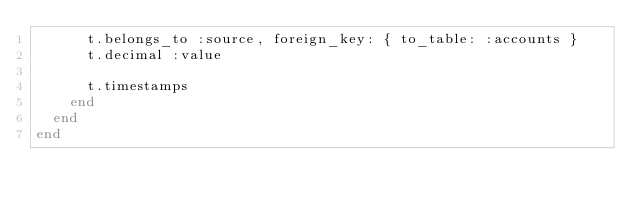Convert code to text. <code><loc_0><loc_0><loc_500><loc_500><_Ruby_>      t.belongs_to :source, foreign_key: { to_table: :accounts }
      t.decimal :value

      t.timestamps
    end
  end
end
</code> 